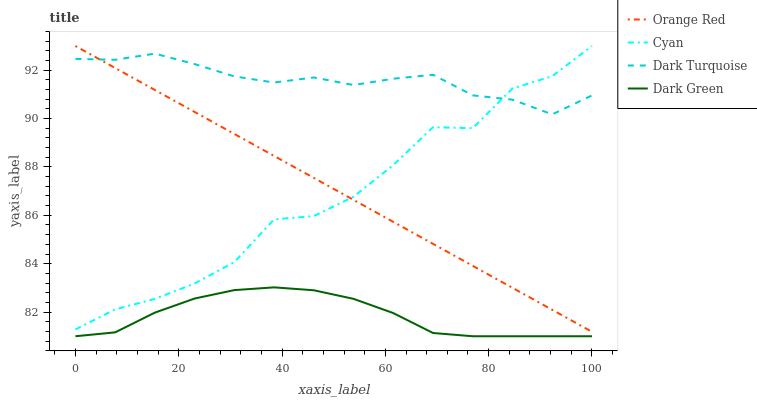Does Dark Green have the minimum area under the curve?
Answer yes or no. Yes. Does Dark Turquoise have the maximum area under the curve?
Answer yes or no. Yes. Does Orange Red have the minimum area under the curve?
Answer yes or no. No. Does Orange Red have the maximum area under the curve?
Answer yes or no. No. Is Orange Red the smoothest?
Answer yes or no. Yes. Is Cyan the roughest?
Answer yes or no. Yes. Is Dark Green the smoothest?
Answer yes or no. No. Is Dark Green the roughest?
Answer yes or no. No. Does Dark Green have the lowest value?
Answer yes or no. Yes. Does Orange Red have the lowest value?
Answer yes or no. No. Does Orange Red have the highest value?
Answer yes or no. Yes. Does Dark Green have the highest value?
Answer yes or no. No. Is Dark Green less than Cyan?
Answer yes or no. Yes. Is Cyan greater than Dark Green?
Answer yes or no. Yes. Does Orange Red intersect Cyan?
Answer yes or no. Yes. Is Orange Red less than Cyan?
Answer yes or no. No. Is Orange Red greater than Cyan?
Answer yes or no. No. Does Dark Green intersect Cyan?
Answer yes or no. No. 